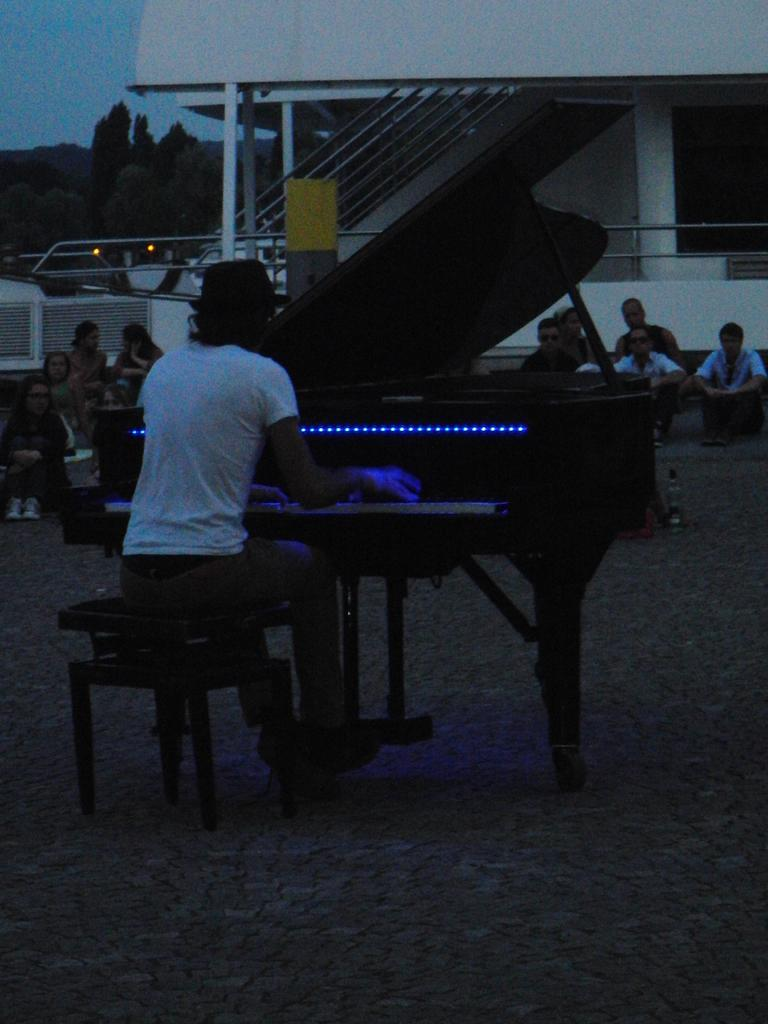What is the man in the image doing? The man is playing the piano in the image. What is the man sitting on while playing the piano? The man is sitting on a stool. Can you describe the people in the background of the image? There are people in the background listening to the music. What architectural features can be seen in the background of the image? There are steps, a building, and a pillar in the background. What type of natural environment is visible in the background of the image? There are trees in the background. What color is the coat the man is wearing while playing the piano in the image? There is no coat mentioned or visible in the image; the man is not wearing a coat while playing the piano. 